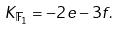Convert formula to latex. <formula><loc_0><loc_0><loc_500><loc_500>K _ { \mathbb { F } _ { 1 } } = - 2 e - 3 f .</formula> 